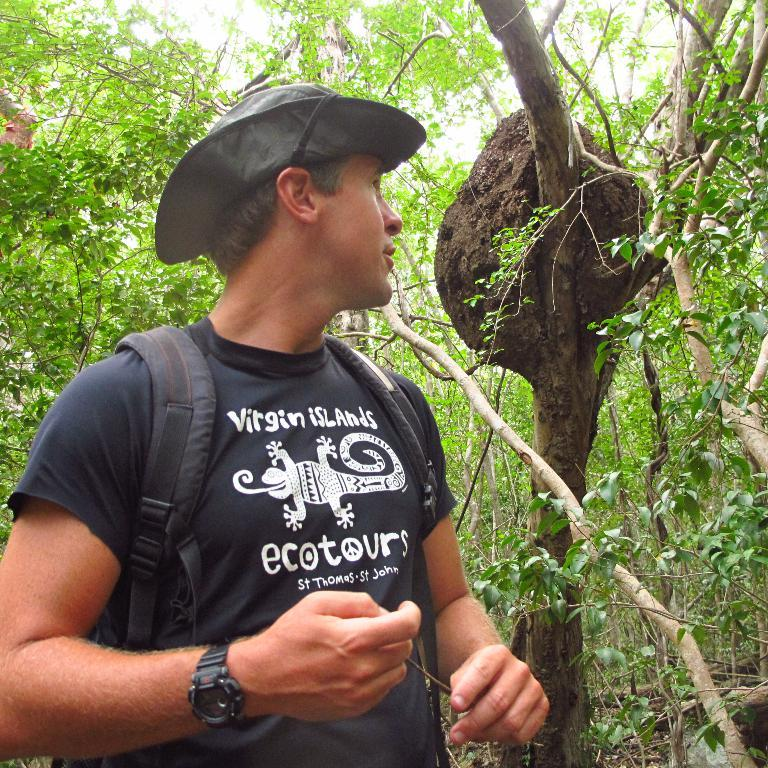Who or what is present in the image? There is a person in the image. What is the person wearing? The person is wearing clothes and a hat. What can be seen in the background of the image? There are trees in the background of the image. What type of pets does the person have in the image? There are no pets visible in the image. 